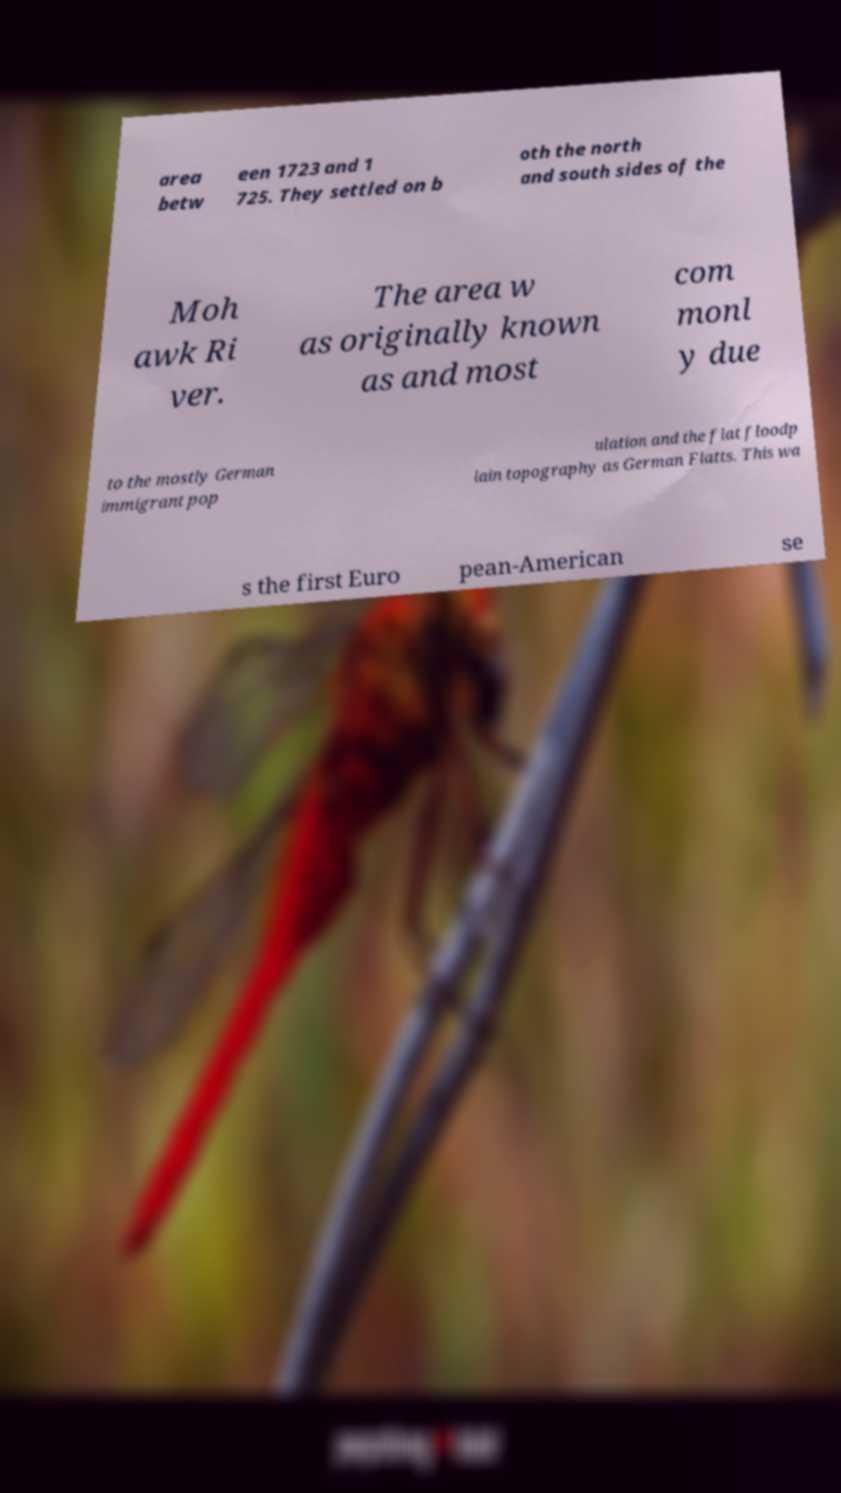Can you read and provide the text displayed in the image?This photo seems to have some interesting text. Can you extract and type it out for me? area betw een 1723 and 1 725. They settled on b oth the north and south sides of the Moh awk Ri ver. The area w as originally known as and most com monl y due to the mostly German immigrant pop ulation and the flat floodp lain topography as German Flatts. This wa s the first Euro pean-American se 